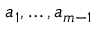Convert formula to latex. <formula><loc_0><loc_0><loc_500><loc_500>a _ { 1 } , \dots , a _ { m - 1 }</formula> 